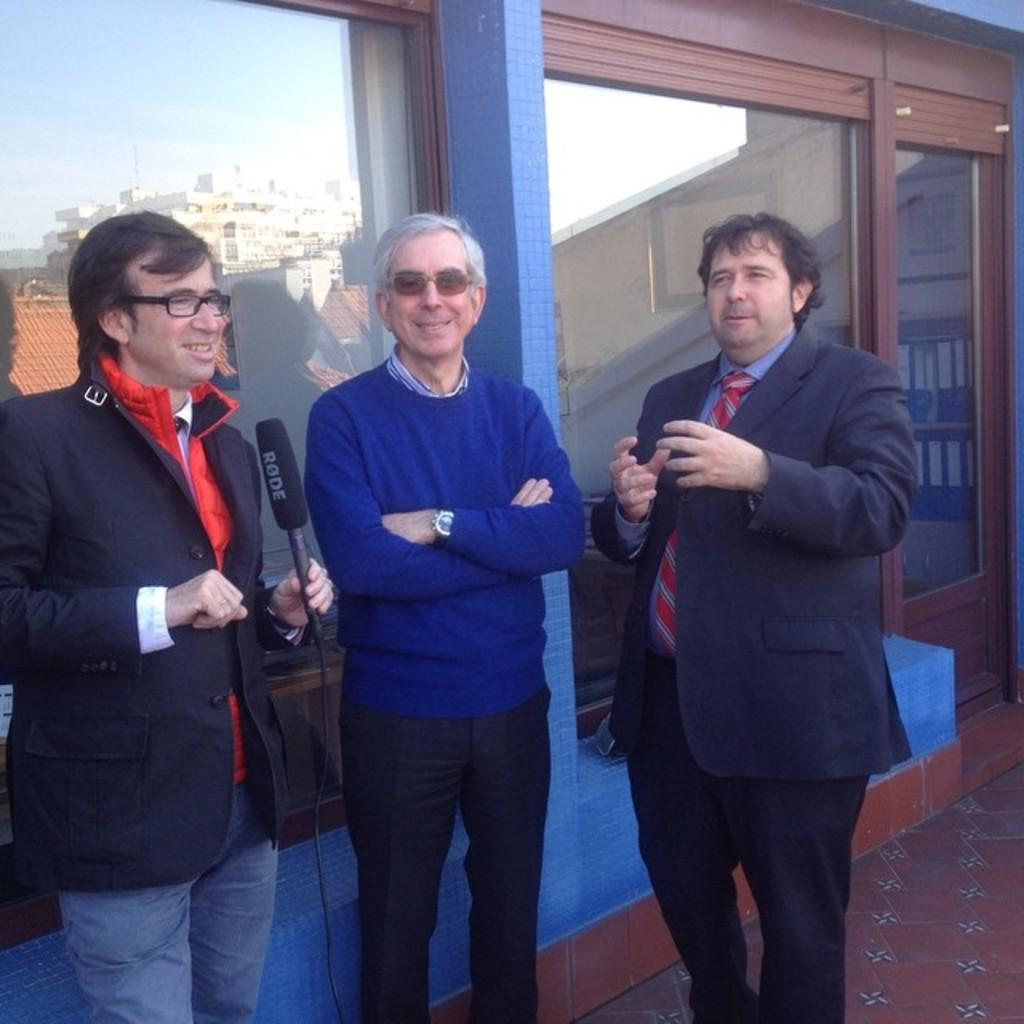How many people are in the image? There are three men standing in the image. What is one of the men holding in his hand? One man is holding a mic in his hand. What can be seen in the background of the image? There is a glass in the background of the image. What is reflected in the glass? The reflection of a building is visible in the glass. What type of cream is being used by the man holding the mic? There is no cream present in the image; the man is holding a mic. 